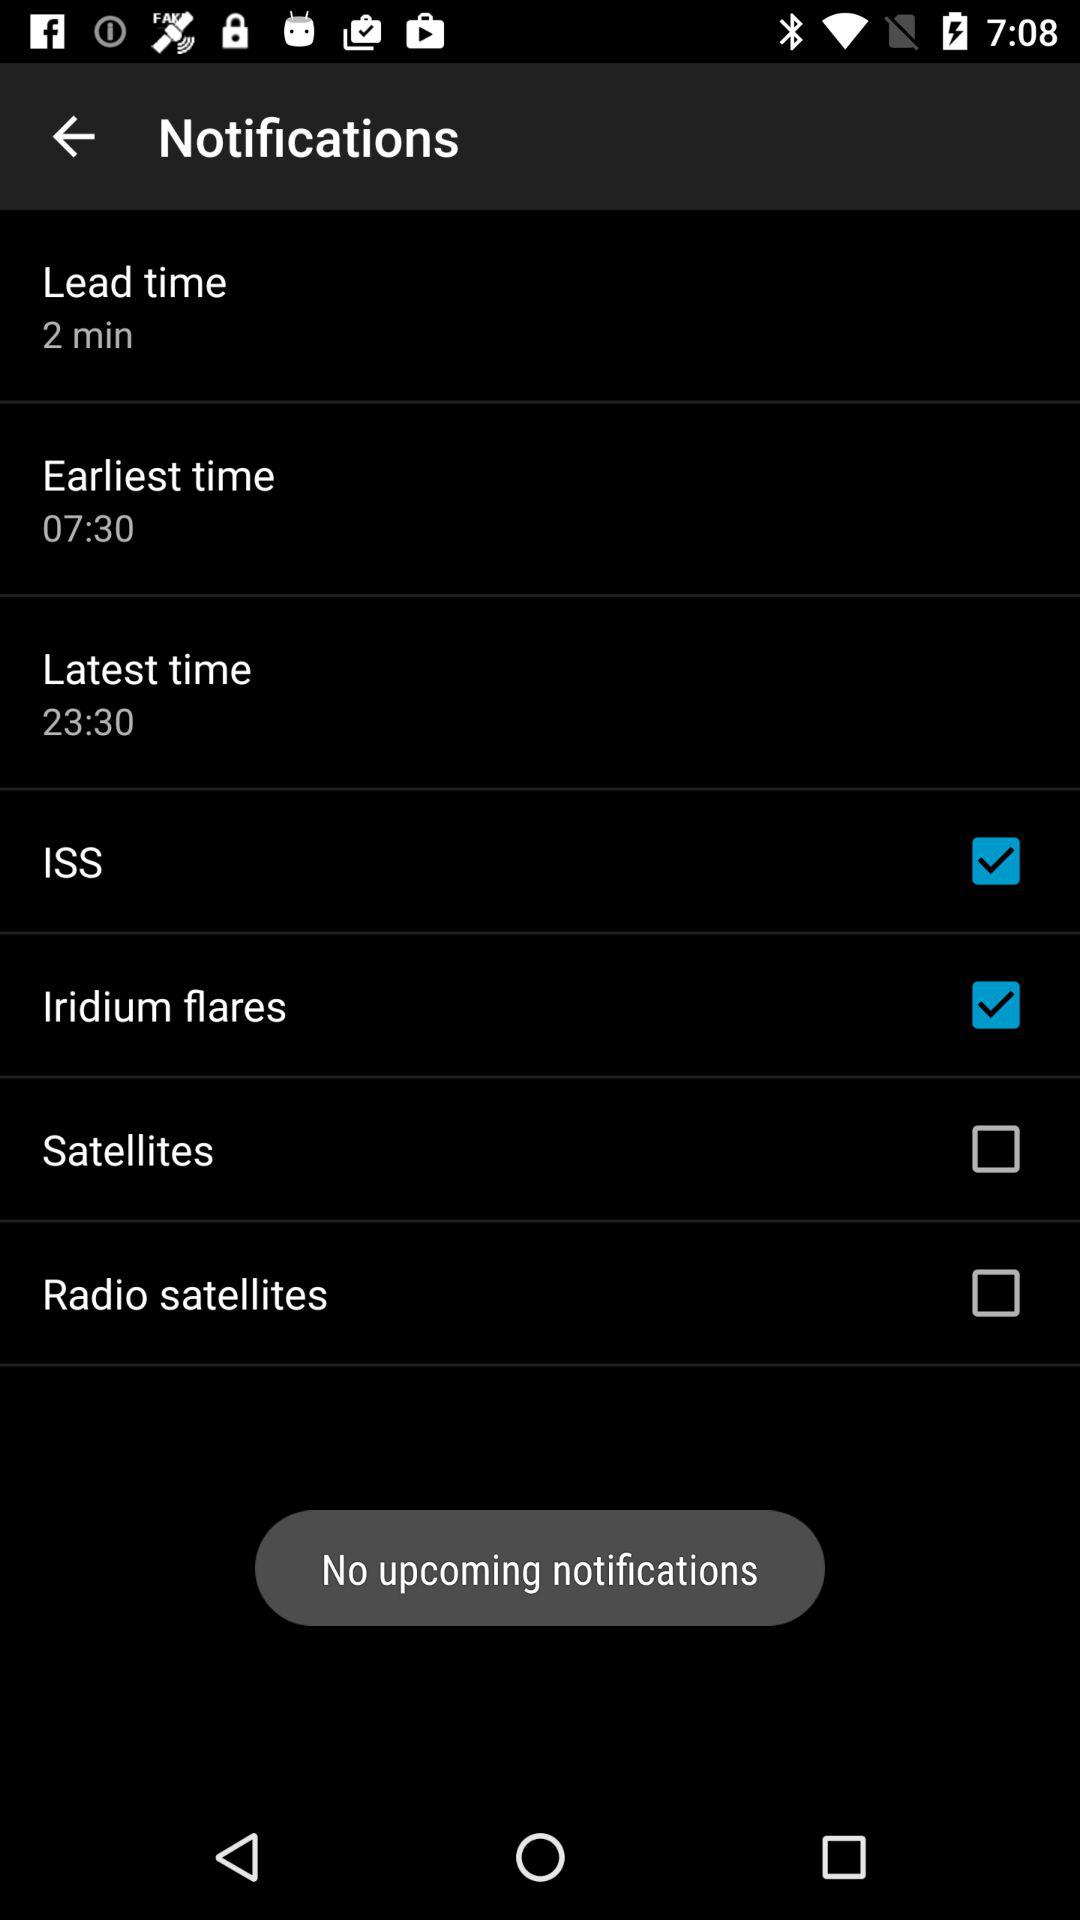What is the lead time? The lead time is 2 minutes. 